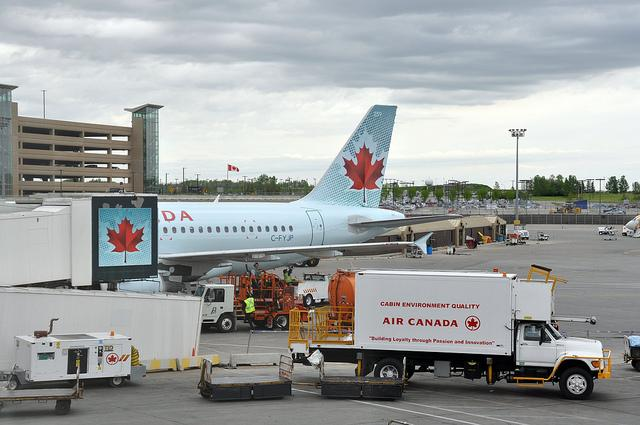What continent is this country located at?

Choices:
A) north america
B) asia
C) south america
D) australia north america 